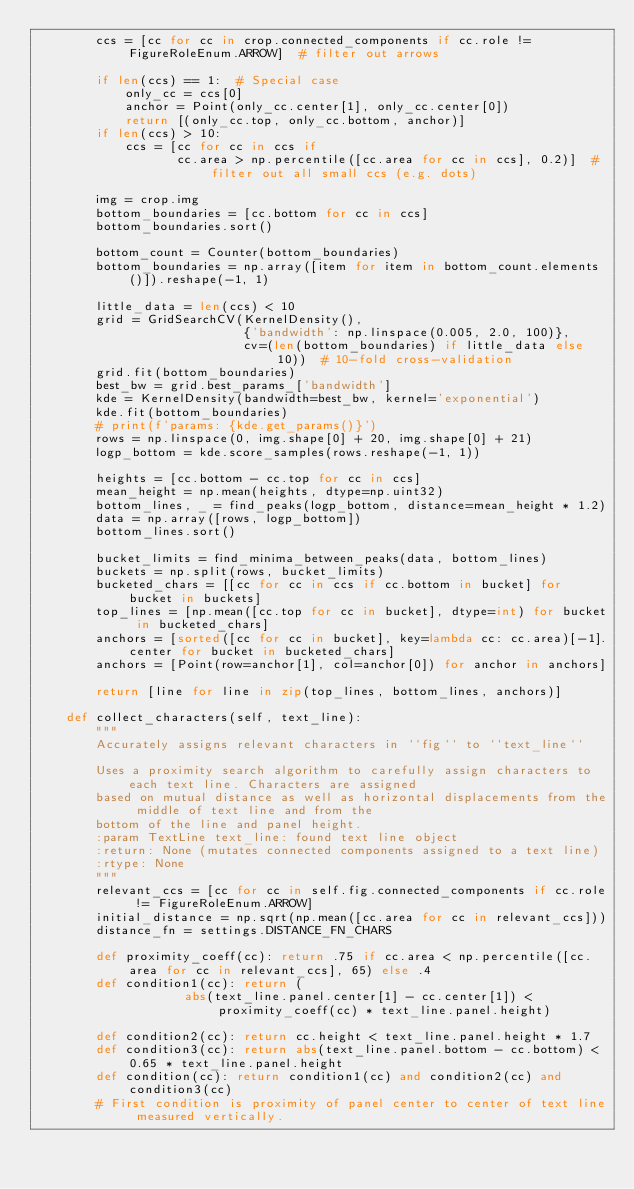Convert code to text. <code><loc_0><loc_0><loc_500><loc_500><_Python_>        ccs = [cc for cc in crop.connected_components if cc.role != FigureRoleEnum.ARROW]  # filter out arrows

        if len(ccs) == 1:  # Special case
            only_cc = ccs[0]
            anchor = Point(only_cc.center[1], only_cc.center[0])
            return [(only_cc.top, only_cc.bottom, anchor)]
        if len(ccs) > 10:
            ccs = [cc for cc in ccs if
                   cc.area > np.percentile([cc.area for cc in ccs], 0.2)]  # filter out all small ccs (e.g. dots)

        img = crop.img
        bottom_boundaries = [cc.bottom for cc in ccs]
        bottom_boundaries.sort()

        bottom_count = Counter(bottom_boundaries)
        bottom_boundaries = np.array([item for item in bottom_count.elements()]).reshape(-1, 1)

        little_data = len(ccs) < 10
        grid = GridSearchCV(KernelDensity(),
                            {'bandwidth': np.linspace(0.005, 2.0, 100)},
                            cv=(len(bottom_boundaries) if little_data else 10))  # 10-fold cross-validation
        grid.fit(bottom_boundaries)
        best_bw = grid.best_params_['bandwidth']
        kde = KernelDensity(bandwidth=best_bw, kernel='exponential')
        kde.fit(bottom_boundaries)
        # print(f'params: {kde.get_params()}')
        rows = np.linspace(0, img.shape[0] + 20, img.shape[0] + 21)
        logp_bottom = kde.score_samples(rows.reshape(-1, 1))

        heights = [cc.bottom - cc.top for cc in ccs]
        mean_height = np.mean(heights, dtype=np.uint32)
        bottom_lines, _ = find_peaks(logp_bottom, distance=mean_height * 1.2)
        data = np.array([rows, logp_bottom])
        bottom_lines.sort()

        bucket_limits = find_minima_between_peaks(data, bottom_lines)
        buckets = np.split(rows, bucket_limits)
        bucketed_chars = [[cc for cc in ccs if cc.bottom in bucket] for bucket in buckets]
        top_lines = [np.mean([cc.top for cc in bucket], dtype=int) for bucket in bucketed_chars]
        anchors = [sorted([cc for cc in bucket], key=lambda cc: cc.area)[-1].center for bucket in bucketed_chars]
        anchors = [Point(row=anchor[1], col=anchor[0]) for anchor in anchors]

        return [line for line in zip(top_lines, bottom_lines, anchors)]

    def collect_characters(self, text_line):
        """
        Accurately assigns relevant characters in ``fig`` to ``text_line``

        Uses a proximity search algorithm to carefully assign characters to each text line. Characters are assigned
        based on mutual distance as well as horizontal displacements from the middle of text line and from the
        bottom of the line and panel height.
        :param TextLine text_line: found text line object
        :return: None (mutates connected components assigned to a text line)
        :rtype: None
        """
        relevant_ccs = [cc for cc in self.fig.connected_components if cc.role != FigureRoleEnum.ARROW]
        initial_distance = np.sqrt(np.mean([cc.area for cc in relevant_ccs]))
        distance_fn = settings.DISTANCE_FN_CHARS

        def proximity_coeff(cc): return .75 if cc.area < np.percentile([cc.area for cc in relevant_ccs], 65) else .4
        def condition1(cc): return (
                    abs(text_line.panel.center[1] - cc.center[1]) < proximity_coeff(cc) * text_line.panel.height)

        def condition2(cc): return cc.height < text_line.panel.height * 1.7
        def condition3(cc): return abs(text_line.panel.bottom - cc.bottom) < 0.65 * text_line.panel.height
        def condition(cc): return condition1(cc) and condition2(cc) and condition3(cc)
        # First condition is proximity of panel center to center of text line measured vertically.</code> 